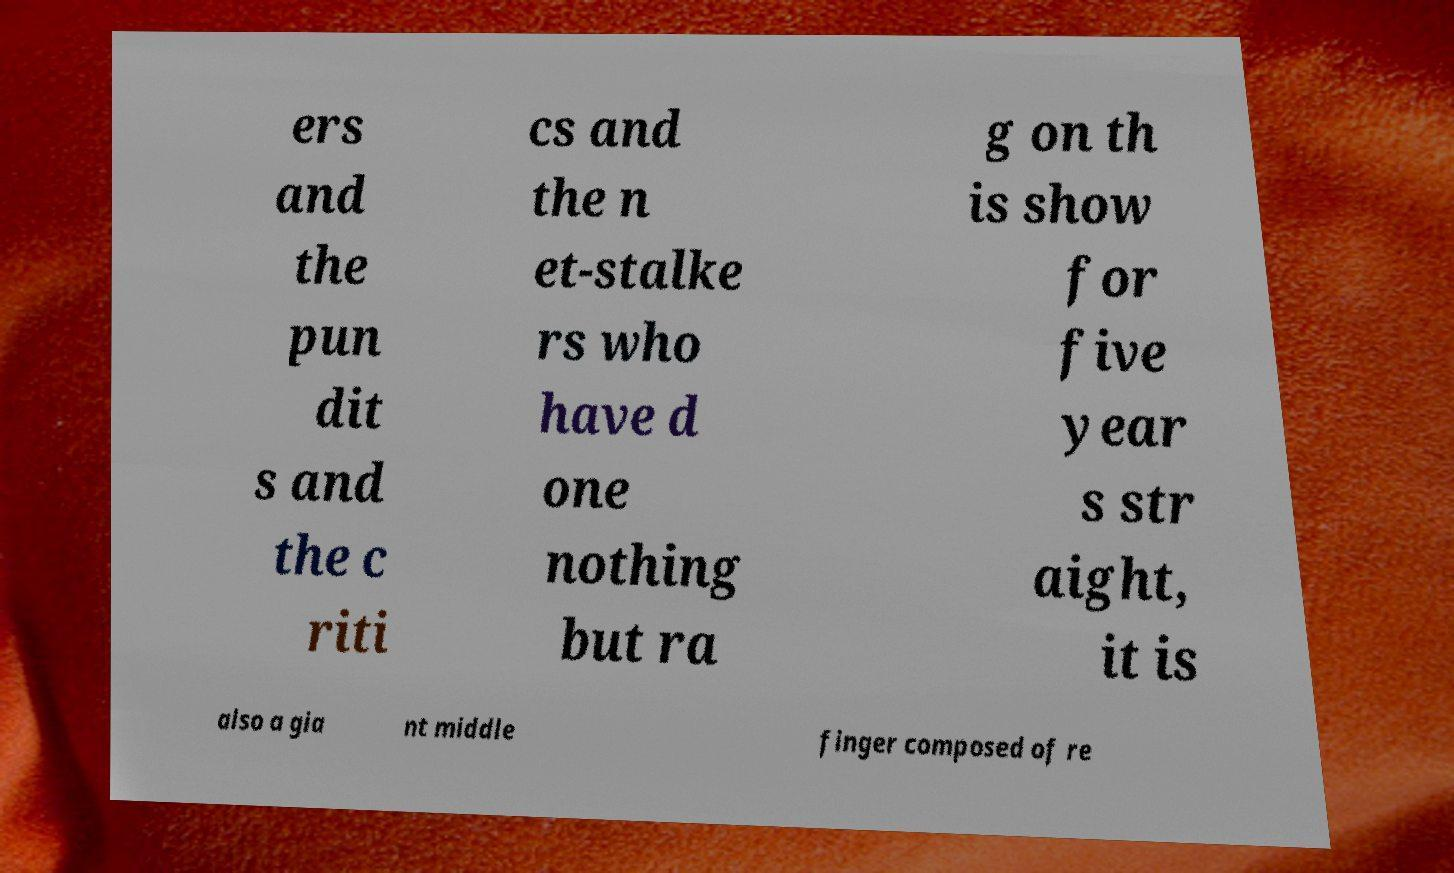Can you read and provide the text displayed in the image?This photo seems to have some interesting text. Can you extract and type it out for me? ers and the pun dit s and the c riti cs and the n et-stalke rs who have d one nothing but ra g on th is show for five year s str aight, it is also a gia nt middle finger composed of re 